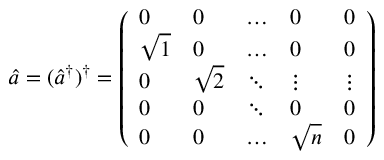Convert formula to latex. <formula><loc_0><loc_0><loc_500><loc_500>\hat { a } = ( \hat { a } ^ { \dagger } ) ^ { \dagger } = \left ( \begin{array} { l l l l l } { 0 } & { 0 } & { \dots } & { 0 } & { 0 } \\ { \sqrt { 1 } } & { 0 } & { \dots } & { 0 } & { 0 } \\ { 0 } & { \sqrt { 2 } } & { \ddots } & { \vdots } & { \vdots } \\ { 0 } & { 0 } & { \ddots } & { 0 } & { 0 } \\ { 0 } & { 0 } & { \dots } & { \sqrt { n } } & { 0 } \end{array} \right )</formula> 